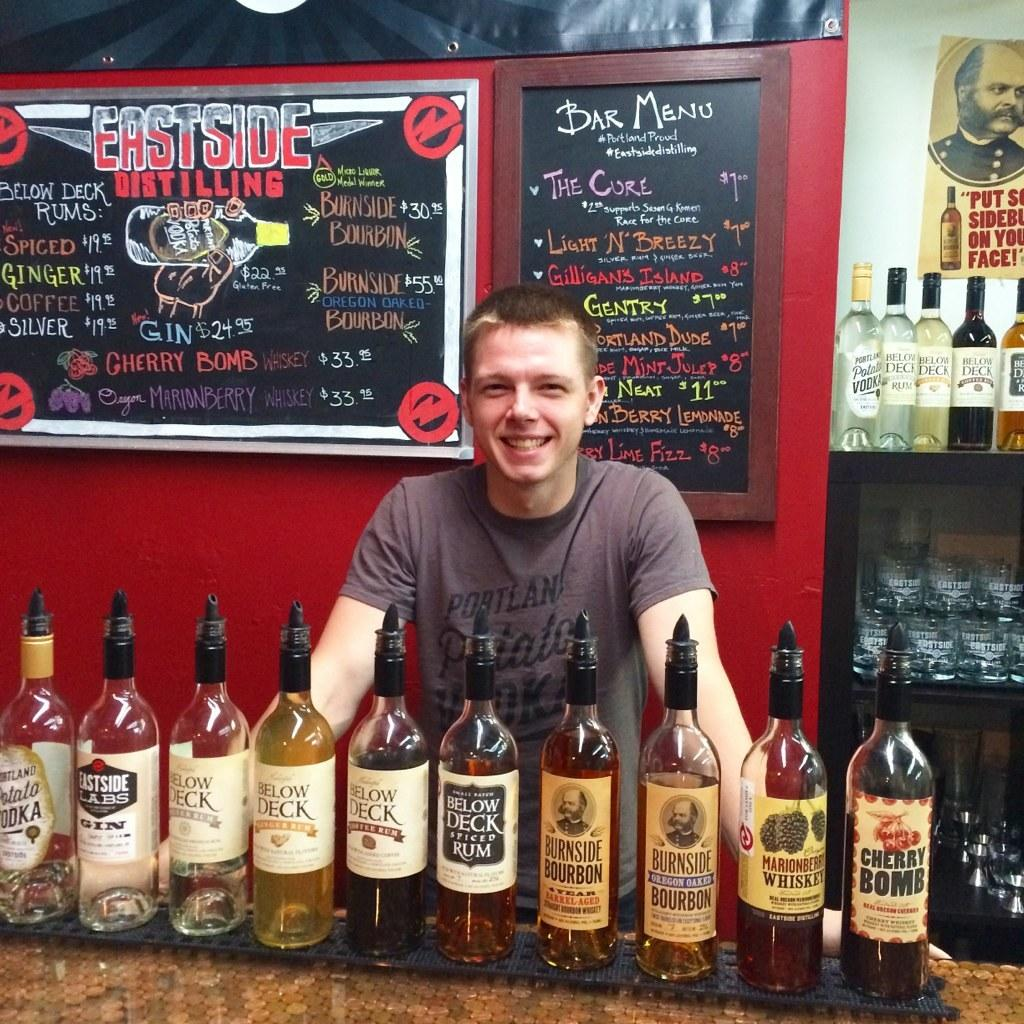<image>
Summarize the visual content of the image. The smiling bartender stands behind many bottles including Marionberry Whiskey. 